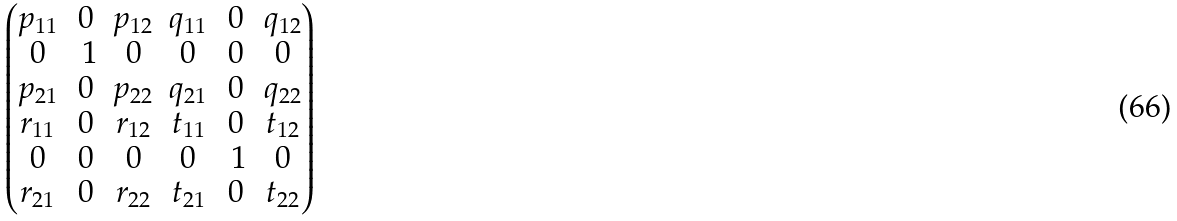<formula> <loc_0><loc_0><loc_500><loc_500>\begin{pmatrix} p _ { 1 1 } & 0 & p _ { 1 2 } & q _ { 1 1 } & 0 & q _ { 1 2 } \\ 0 & \ 1 & 0 & 0 & 0 & 0 \\ p _ { 2 1 } & 0 & p _ { 2 2 } & q _ { 2 1 } & 0 & q _ { 2 2 } \\ r _ { 1 1 } & 0 & r _ { 1 2 } & t _ { 1 1 } & 0 & t _ { 1 2 } \\ 0 & 0 & 0 & 0 & \ 1 & 0 \\ r _ { 2 1 } & 0 & r _ { 2 2 } & t _ { 2 1 } & 0 & t _ { 2 2 } \end{pmatrix}</formula> 